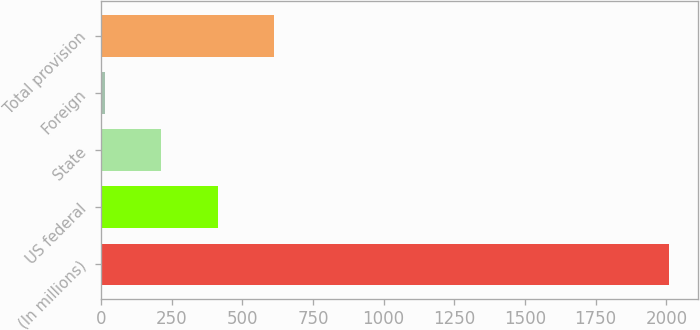Convert chart. <chart><loc_0><loc_0><loc_500><loc_500><bar_chart><fcel>(In millions)<fcel>US federal<fcel>State<fcel>Foreign<fcel>Total provision<nl><fcel>2010<fcel>413.44<fcel>213.87<fcel>14.3<fcel>613.01<nl></chart> 